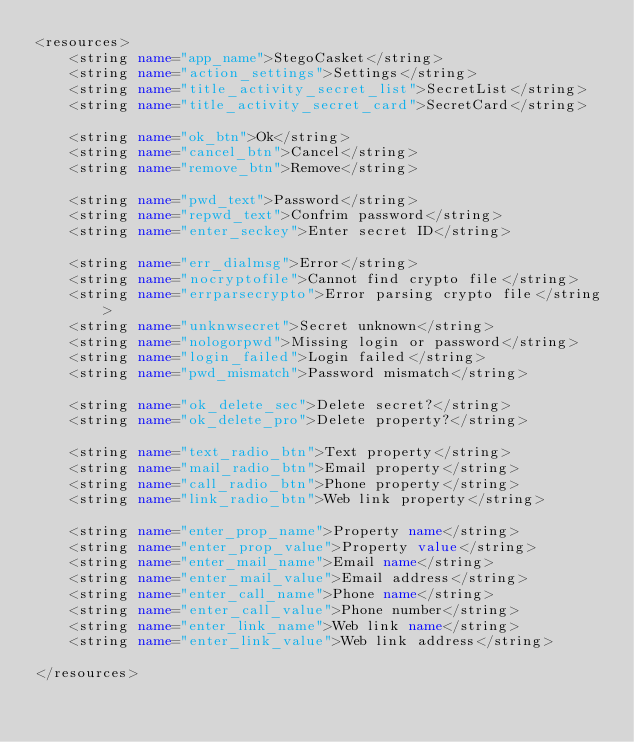<code> <loc_0><loc_0><loc_500><loc_500><_XML_><resources>
    <string name="app_name">StegoCasket</string>
    <string name="action_settings">Settings</string>
    <string name="title_activity_secret_list">SecretList</string>
    <string name="title_activity_secret_card">SecretCard</string>

    <string name="ok_btn">Ok</string>
    <string name="cancel_btn">Cancel</string>
    <string name="remove_btn">Remove</string>

    <string name="pwd_text">Password</string>
    <string name="repwd_text">Confrim password</string>
    <string name="enter_seckey">Enter secret ID</string>

    <string name="err_dialmsg">Error</string>
    <string name="nocryptofile">Cannot find crypto file</string>
    <string name="errparsecrypto">Error parsing crypto file</string>
    <string name="unknwsecret">Secret unknown</string>
    <string name="nologorpwd">Missing login or password</string>
    <string name="login_failed">Login failed</string>
    <string name="pwd_mismatch">Password mismatch</string>

    <string name="ok_delete_sec">Delete secret?</string>
    <string name="ok_delete_pro">Delete property?</string>

    <string name="text_radio_btn">Text property</string>
    <string name="mail_radio_btn">Email property</string>
    <string name="call_radio_btn">Phone property</string>
    <string name="link_radio_btn">Web link property</string>

    <string name="enter_prop_name">Property name</string>
    <string name="enter_prop_value">Property value</string>
    <string name="enter_mail_name">Email name</string>
    <string name="enter_mail_value">Email address</string>
    <string name="enter_call_name">Phone name</string>
    <string name="enter_call_value">Phone number</string>
    <string name="enter_link_name">Web link name</string>
    <string name="enter_link_value">Web link address</string>

</resources>
</code> 